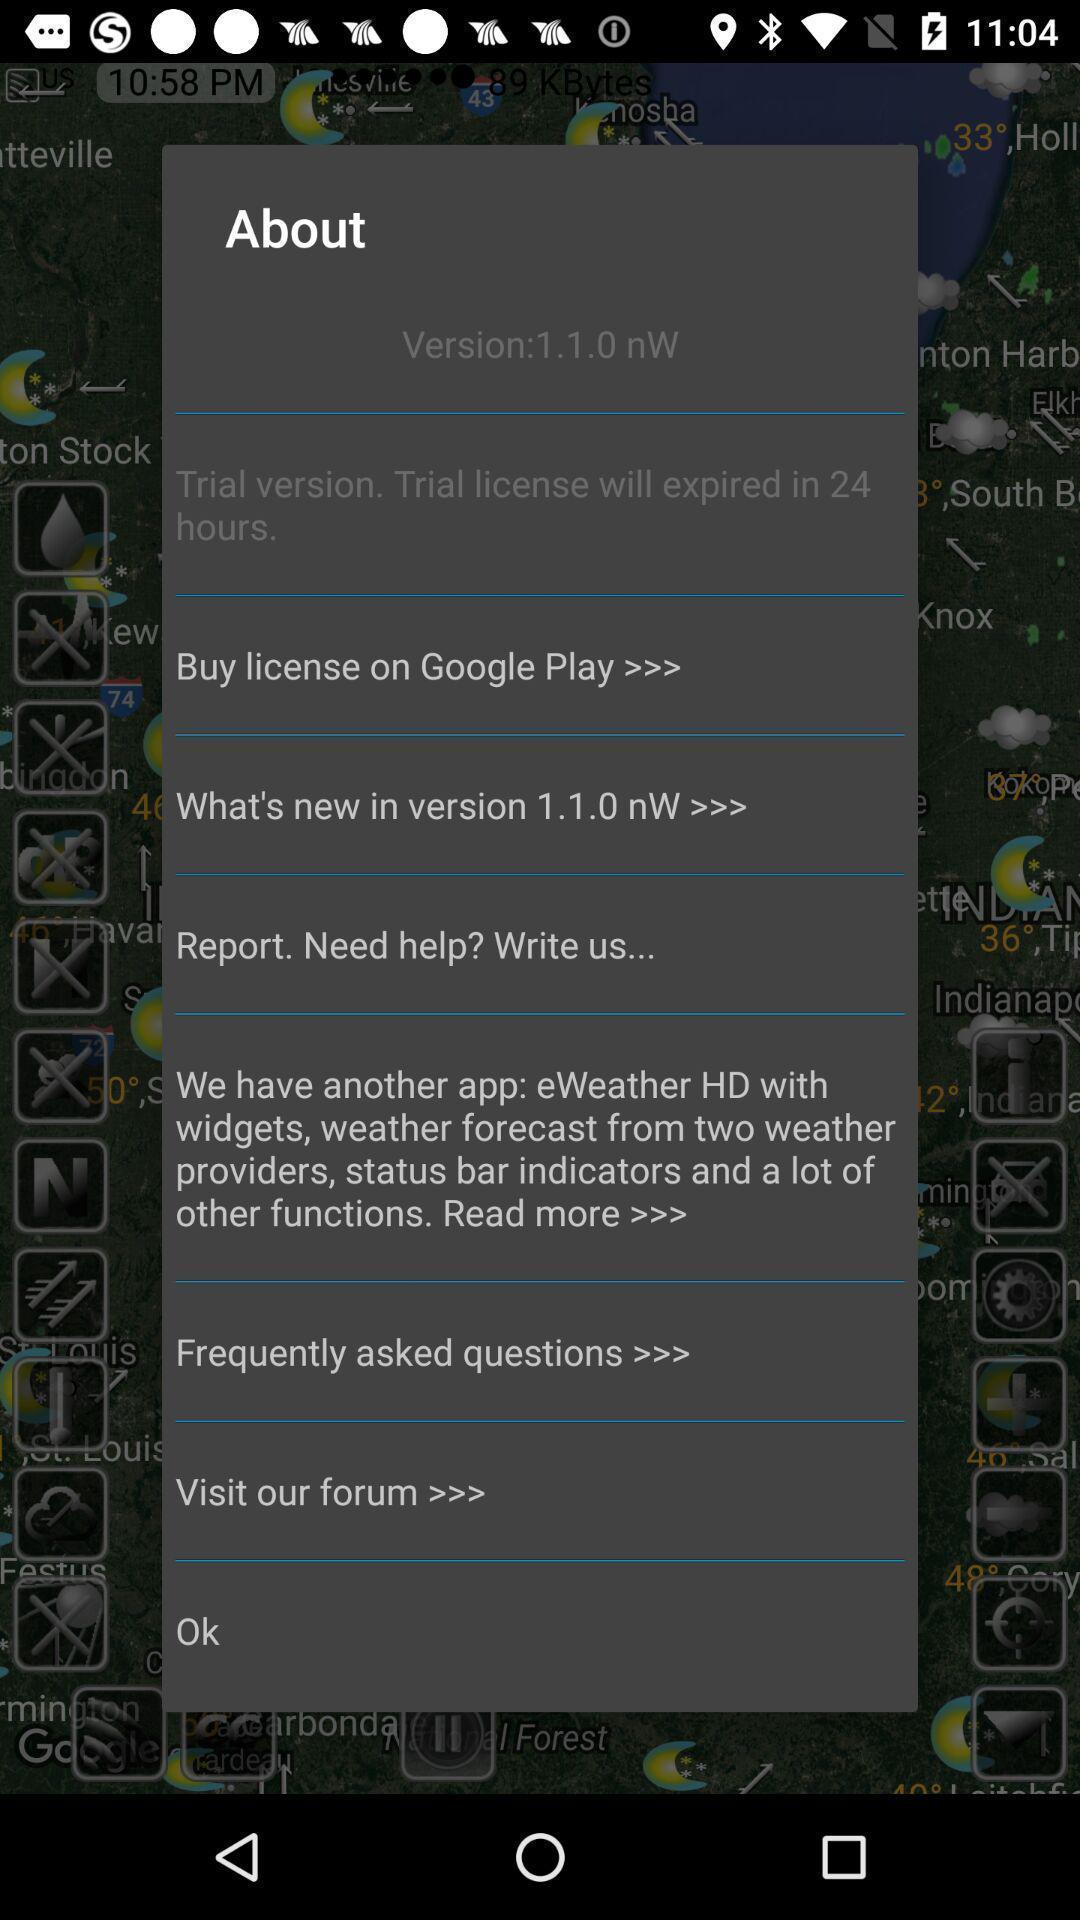Provide a description of this screenshot. Pop-up showing list of information about the app. 